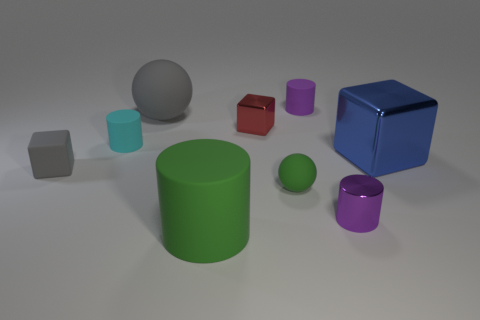Does the metallic block that is behind the blue metal block have the same color as the big metallic block?
Provide a succinct answer. No. How many metallic things are either green balls or big cylinders?
Your response must be concise. 0. Is there anything else that is the same size as the cyan rubber cylinder?
Make the answer very short. Yes. The block that is made of the same material as the tiny red object is what color?
Provide a succinct answer. Blue. What number of balls are either tiny yellow objects or small green things?
Give a very brief answer. 1. How many objects are tiny cyan cubes or gray objects that are on the left side of the tiny red object?
Provide a succinct answer. 2. Are any yellow shiny objects visible?
Offer a very short reply. No. How many things have the same color as the matte cube?
Offer a very short reply. 1. What is the material of the sphere that is the same color as the matte cube?
Provide a short and direct response. Rubber. There is a gray object that is right of the small block in front of the tiny cyan rubber cylinder; what size is it?
Give a very brief answer. Large. 